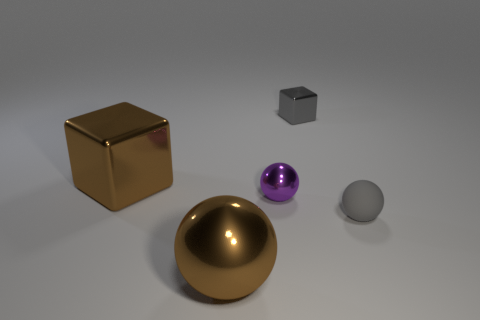Add 3 tiny blue rubber things. How many objects exist? 8 Subtract all spheres. How many objects are left? 2 Subtract all purple metal objects. Subtract all large brown shiny blocks. How many objects are left? 3 Add 4 small metal blocks. How many small metal blocks are left? 5 Add 3 small blue matte cylinders. How many small blue matte cylinders exist? 3 Subtract 0 cyan cylinders. How many objects are left? 5 